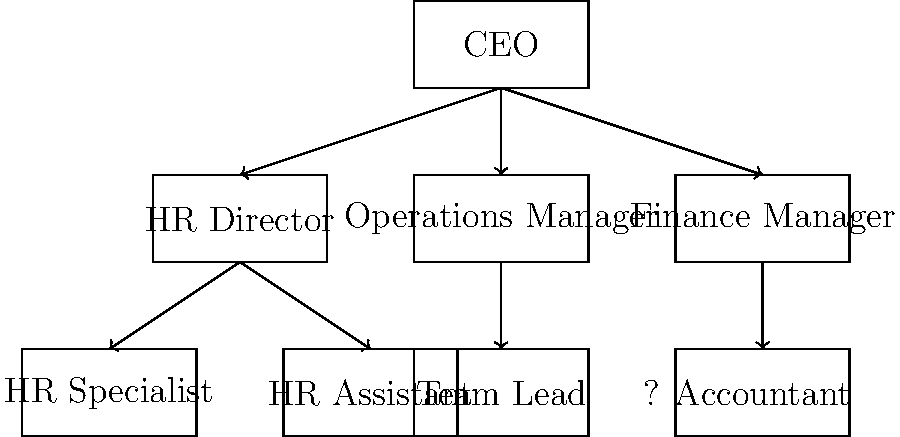In the organizational chart shown above, which position is missing and should be placed where the question mark is located? To determine the missing position, let's analyze the organizational chart step-by-step:

1. The CEO is at the top of the hierarchy.
2. Under the CEO, there are three main departments: HR, Operations, and Finance.
3. Each department has a director or manager:
   - HR Director
   - Operations Manager
   - Finance Manager
4. Under the HR Director, we see two positions:
   - HR Specialist
   - HR Assistant
5. Under the Operations Manager, we see one position:
   - Team Lead
6. Under the Finance Manager, we see one position:
   - Accountant

Now, let's consider the structure and balance of the chart:
7. The Finance department has only one subordinate position (Accountant).
8. The question mark is placed at the same level as the Accountant, suggesting it should be another finance-related position.
9. In most organizations, a common finance position that works alongside an Accountant is a Financial Analyst.

Therefore, the missing position that would logically fit in the organizational structure and balance the Finance department is a Financial Analyst.
Answer: Financial Analyst 